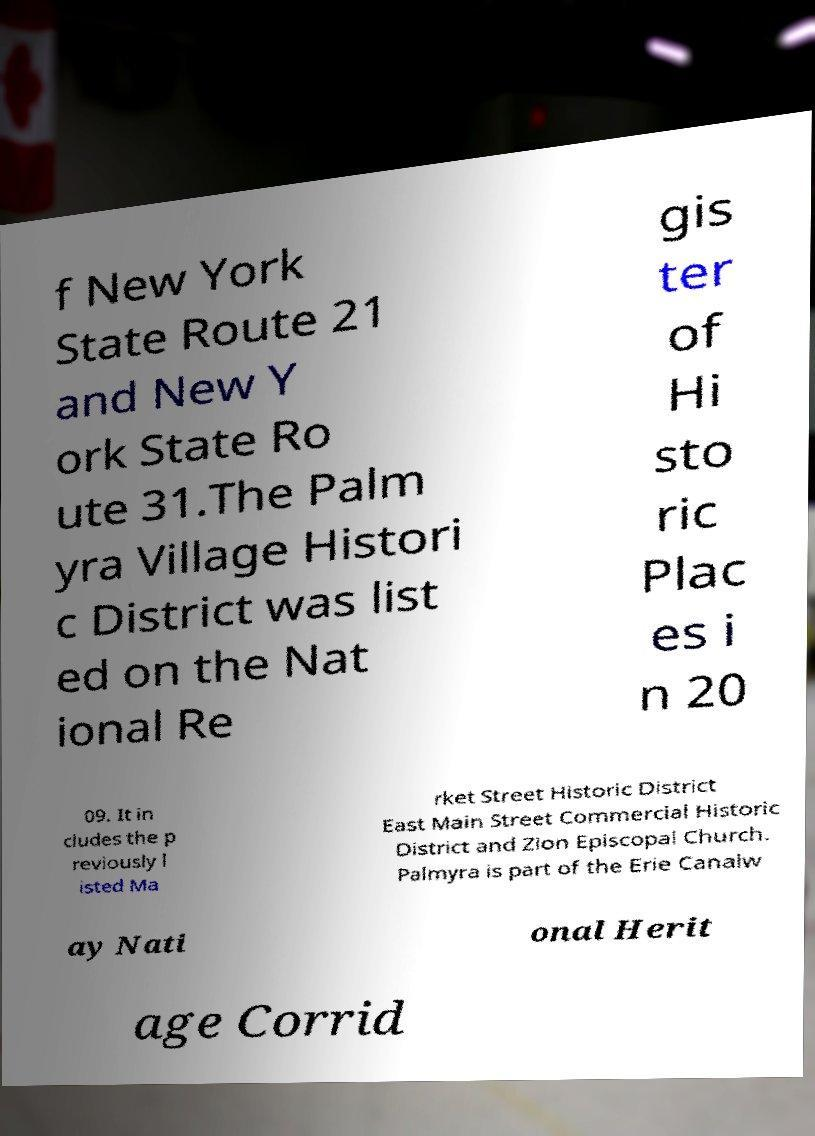Could you assist in decoding the text presented in this image and type it out clearly? f New York State Route 21 and New Y ork State Ro ute 31.The Palm yra Village Histori c District was list ed on the Nat ional Re gis ter of Hi sto ric Plac es i n 20 09. It in cludes the p reviously l isted Ma rket Street Historic District East Main Street Commercial Historic District and Zion Episcopal Church. Palmyra is part of the Erie Canalw ay Nati onal Herit age Corrid 